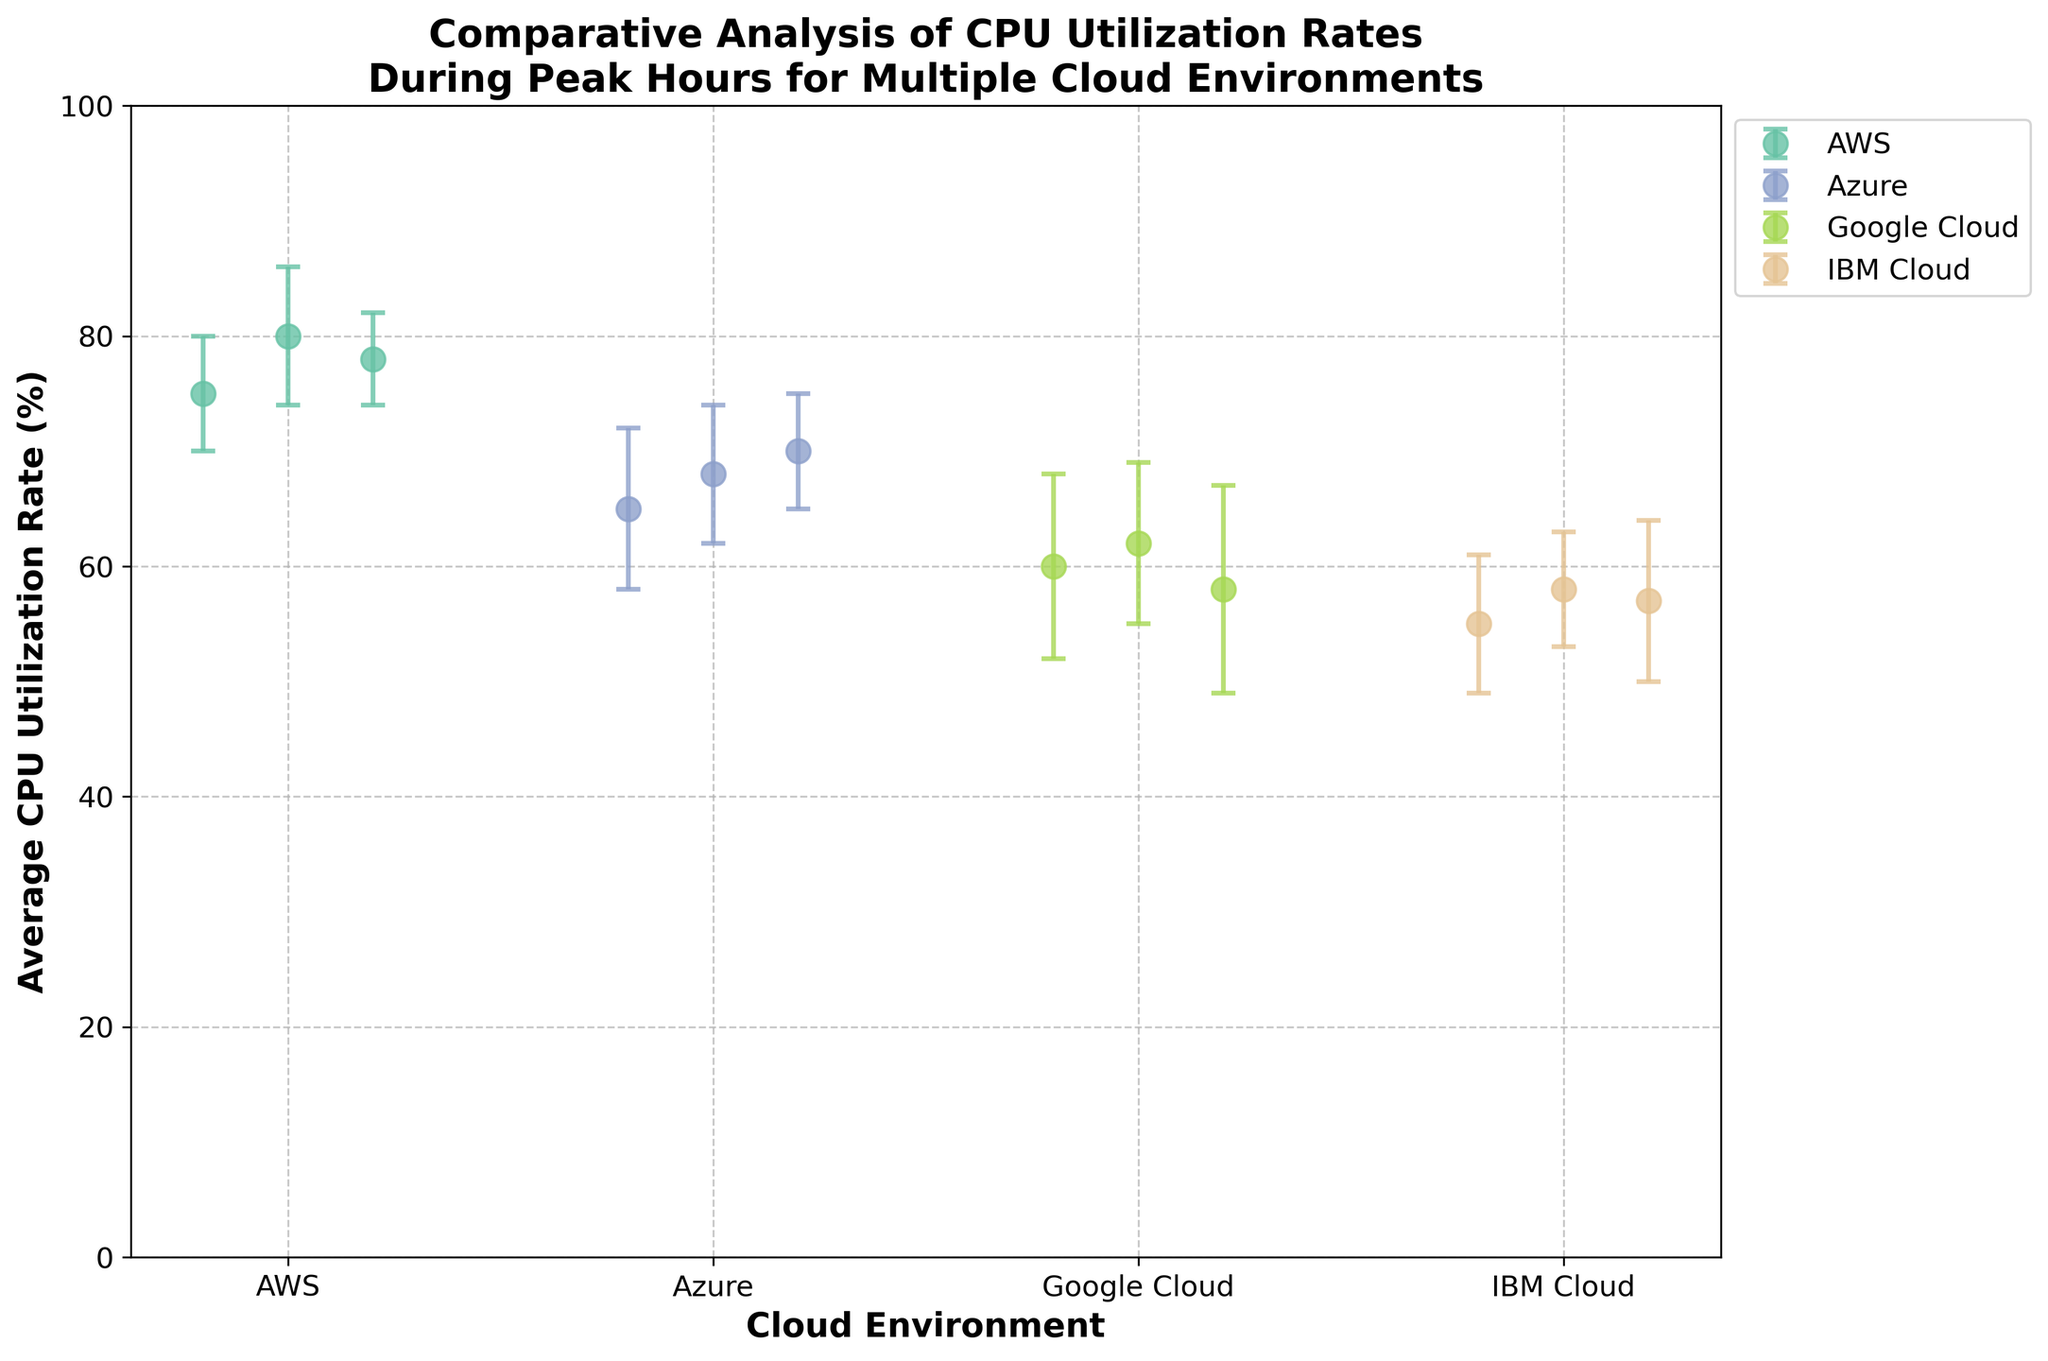What's the title of the figure? The title of the figure is clearly shown at the top as "Comparative Analysis of CPU Utilization Rates During Peak Hours for Multiple Cloud Environments".
Answer: Comparative Analysis of CPU Utilization Rates During Peak Hours for Multiple Cloud Environments What is the average CPU utilization rate for AWS? From the figure, the data points for AWS have average CPU utilization rates of 75%, 80%, and 78%. To find the average, we sum these values and divide by the number of data points: (75 + 80 + 78) / 3 = 77.67%.
Answer: 77.67% Which cloud environment has the highest average CPU utilization rate? By examining the data points and their average positions on the plot, AWS has the highest values (75%, 80%, 78%), indicating that it has the highest average utilization rate.
Answer: AWS For Azure, what is the average standard deviation of CPU utilization rates? Azure has standard deviations of 7%, 6%, and 5%. To find the average standard deviation: (7 + 6 + 5) / 3 = 6%.
Answer: 6% How do the average CPU utilization rates of Google Cloud compare to IBM Cloud? Google Cloud's average CPU utilization rates are 60%, 62%, and 58%. IBM Cloud's rates are 55%, 58%, and 57%. To compare, we find the average for both: Google Cloud (60 + 62 + 58) / 3 = 60%, IBM Cloud (55 + 58 + 57) / 3 = 56.67%. Google Cloud's average is higher than IBM Cloud's.
Answer: Google Cloud's average is higher Which cloud environment has the largest error bar? The largest error bars represent the standard deviations. Visually, Google Cloud's error bars appear to be the largest, as they have the highest standard deviations (8%, 7%, 9%).
Answer: Google Cloud What is the range of CPU utilization rates for Azure? Azure's data points indicate CPU utilization rates of 65%, 68%, and 70%. The range is the difference between the highest and lowest values: 70% - 65% = 5%.
Answer: 5% Which cloud environment has the most consistent CPU utilization rates based on standard deviation? Consistency is indicated by lower standard deviations. AWS has standard deviations of 5%, 6%, and 4%, which are generally lower than those of the other environments.
Answer: AWS Are the CPU utilization rates of IBM Cloud generally lower than those of AWS? By comparing the data points, IBM Cloud's rates are 55%, 58%, and 57%, while AWS has rates of 75%, 80%, and 78%. Clearly, IBM Cloud's utilization rates are lower.
Answer: Yes What is the average CPU utilization rate across all cloud environments? To find the overall average, we sum all the utilization rates and divide by the total number of data points: (75 + 80 + 78 + 65 + 68 + 70 + 60 + 62 + 58 + 55 + 58 + 57) / 12 = 66.75%.
Answer: 66.75% 